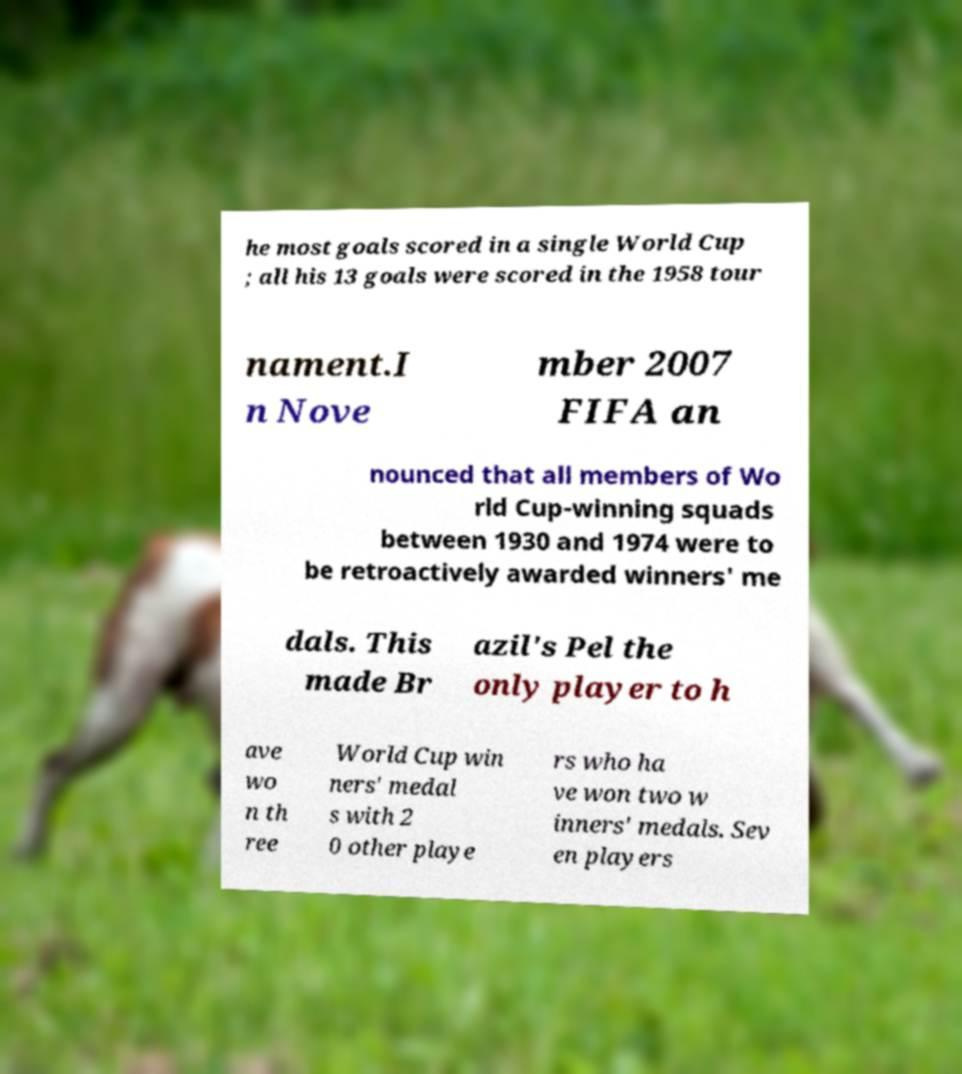Please identify and transcribe the text found in this image. he most goals scored in a single World Cup ; all his 13 goals were scored in the 1958 tour nament.I n Nove mber 2007 FIFA an nounced that all members of Wo rld Cup-winning squads between 1930 and 1974 were to be retroactively awarded winners' me dals. This made Br azil's Pel the only player to h ave wo n th ree World Cup win ners' medal s with 2 0 other playe rs who ha ve won two w inners' medals. Sev en players 